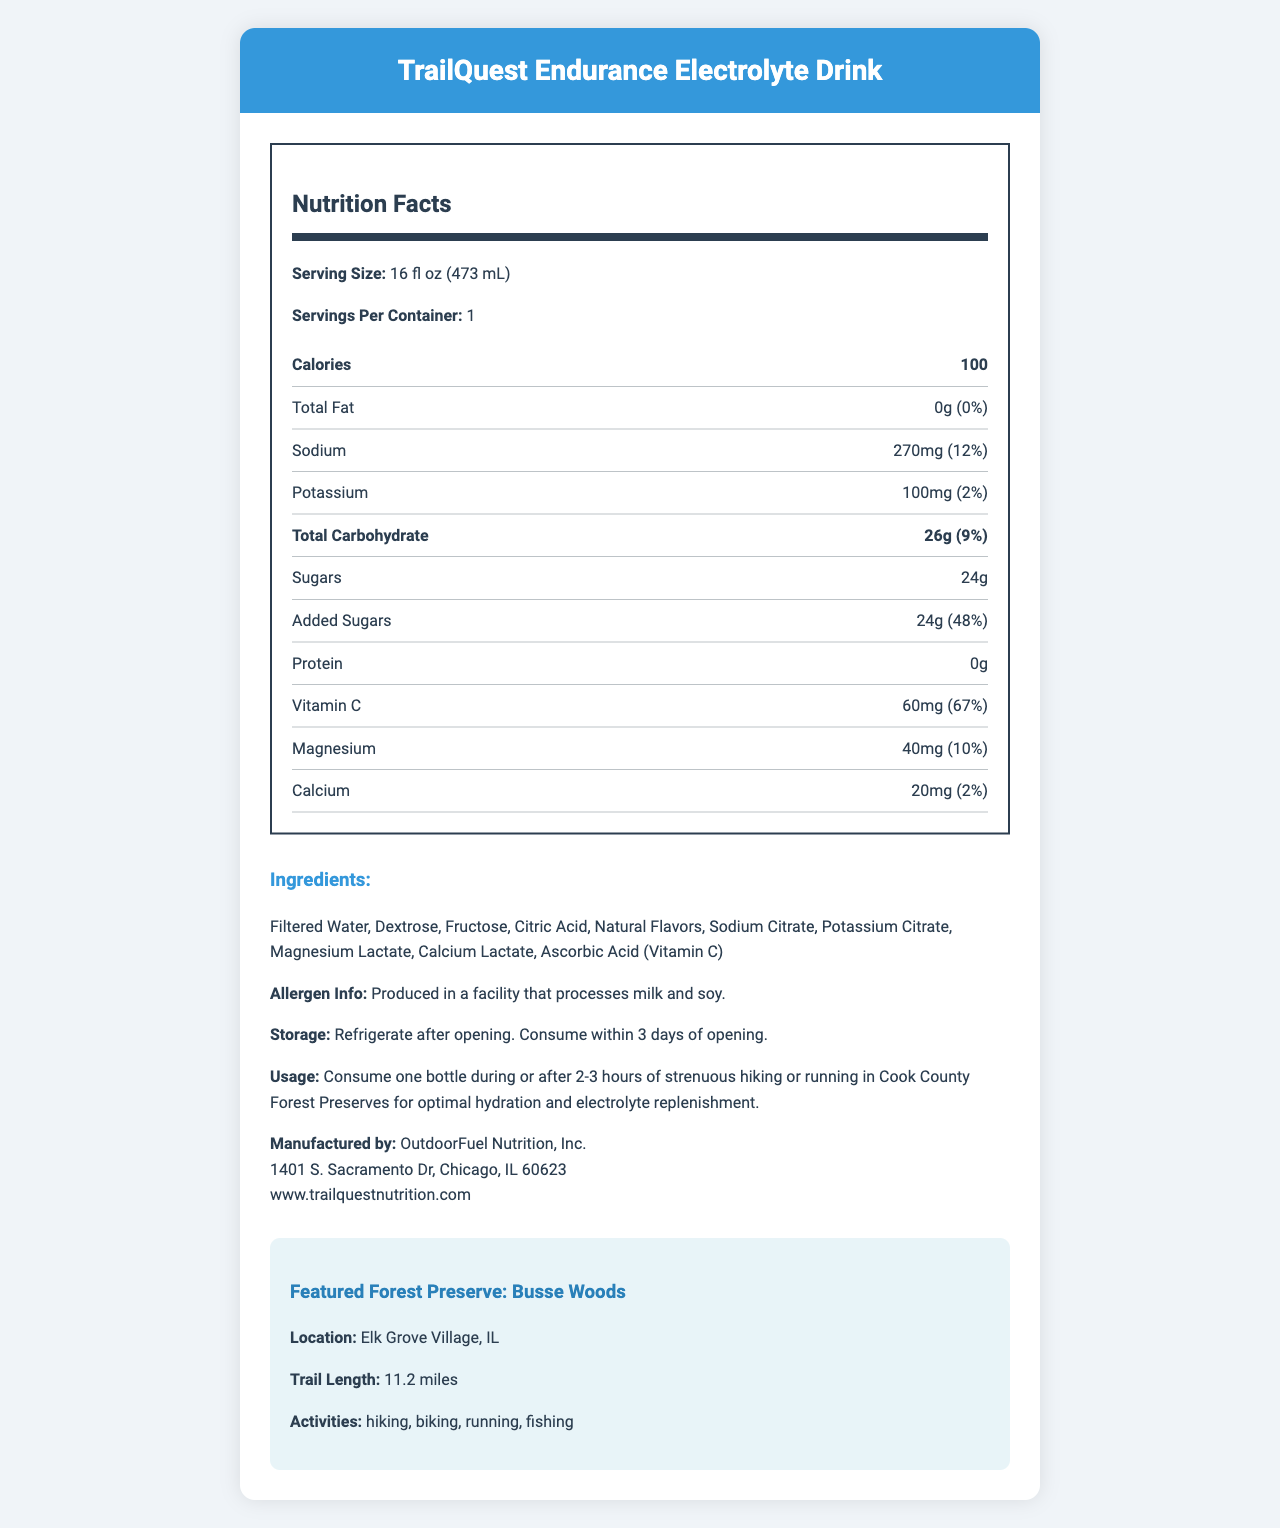what is the serving size for TrailQuest Endurance Electrolyte Drink? The serving size is clearly mentioned as "16 fl oz (473 mL)" in the nutrition label.
Answer: 16 fl oz (473 mL) how many calories are there in one serving? The nutrition label lists the calorie content as 100 calories per serving.
Answer: 100 what percentage of the daily value of vitamin C does the drink provide? The nutrition label states that the drink provides 60mg of Vitamin C, which is 67% of the daily value.
Answer: 67% how much sugar is there per serving? The total sugar content per serving is listed as 24g on the nutrition label.
Answer: 24g how much sodium is there in one serving? The nutrition label specifies that there is 270mg of sodium per serving.
Answer: 270mg what is the name of the featured forest preserve? The featured forest preserve is mentioned as "Busse Woods" in the document.
Answer: Busse Woods what is the primary purpose of the TrailQuest Endurance Electrolyte Drink? A. To boost energy B. To aid in relaxation C. For hydration and electrolyte replenishment D. To improve digestion The usage instructions suggest that the drink is for optimal hydration and electrolyte replenishment.
Answer: C is there any protein in the drink? The nutrition label shows that the protein content is 0g, indicating no protein.
Answer: No what are the storage instructions for the drink? The document provides these specific storage instructions for the drink.
Answer: Refrigerate after opening. Consume within 3 days of opening. how much magnesium is provided per serving? The nutrition label lists the magnesium content as 40mg per serving.
Answer: 40mg is the product safe for someone with a soy allergy? The allergen information states that the product is produced in a facility that processes soy.
Answer: No summarize the main idea of this document. The document contains detailed nutrition information, ingredient list, and usage instructions for a sports drink tailored for long-distance hikers, along with allergen info, manufacturer details, and featured outdoor activity location.
Answer: The TrailQuest Endurance Electrolyte Drink is designed for long-distance hikers and provides key nutrients such as sodium, potassium, vitamin C, and magnesium. It is highlighted for use during or after strenuous activities for hydration and electrolyte replenishment. It also features a specific forest preserve for outdoor activities. how many activities are listed for Busse Woods? The document lists four activities: hiking, biking, running, and fishing.
Answer: 4 what is the total carbohydrate content per serving? The nutrition label indicates that the total carbohydrate content is 26g per serving.
Answer: 26g what percentage of the daily value of calcium does the drink provide? The drink provides 20mg of calcium, which is 2% of the daily value.
Answer: 2% who is the manufacturer of the TrailQuest Endurance Electrolyte Drink? The manufacturer's information provided is "OutdoorFuel Nutrition, Inc."
Answer: OutdoorFuel Nutrition, Inc. how long does the trail in Busse Woods stretch? The document mentions that the trail length in Busse Woods is 11.2 miles.
Answer: 11.2 miles are there any natural flavors in the ingredient list? The ingredients list includes "Natural Flavors."
Answer: Yes how many servings per container are there? The nutrition label states that there is 1 serving per container.
Answer: 1 are there any preservatives in the TrailQuest Endurance Electrolyte Drink? The given document does not indicate whether preservatives are included or not in the drink.
Answer: Not enough information 